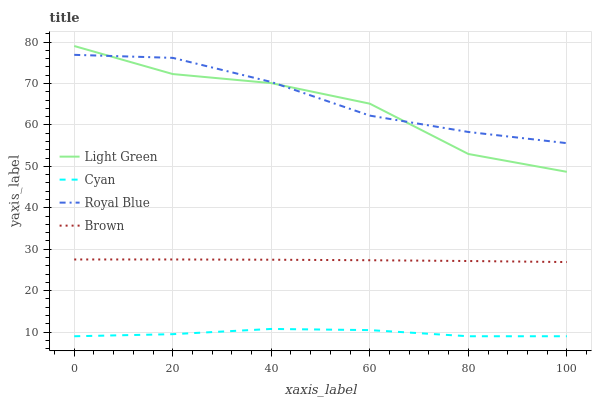Does Cyan have the minimum area under the curve?
Answer yes or no. Yes. Does Royal Blue have the maximum area under the curve?
Answer yes or no. Yes. Does Brown have the minimum area under the curve?
Answer yes or no. No. Does Brown have the maximum area under the curve?
Answer yes or no. No. Is Brown the smoothest?
Answer yes or no. Yes. Is Light Green the roughest?
Answer yes or no. Yes. Is Light Green the smoothest?
Answer yes or no. No. Is Brown the roughest?
Answer yes or no. No. Does Cyan have the lowest value?
Answer yes or no. Yes. Does Brown have the lowest value?
Answer yes or no. No. Does Light Green have the highest value?
Answer yes or no. Yes. Does Brown have the highest value?
Answer yes or no. No. Is Brown less than Royal Blue?
Answer yes or no. Yes. Is Royal Blue greater than Brown?
Answer yes or no. Yes. Does Light Green intersect Royal Blue?
Answer yes or no. Yes. Is Light Green less than Royal Blue?
Answer yes or no. No. Is Light Green greater than Royal Blue?
Answer yes or no. No. Does Brown intersect Royal Blue?
Answer yes or no. No. 